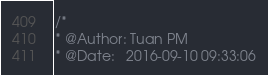<code> <loc_0><loc_0><loc_500><loc_500><_C_>/*
* @Author: Tuan PM
* @Date:   2016-09-10 09:33:06</code> 